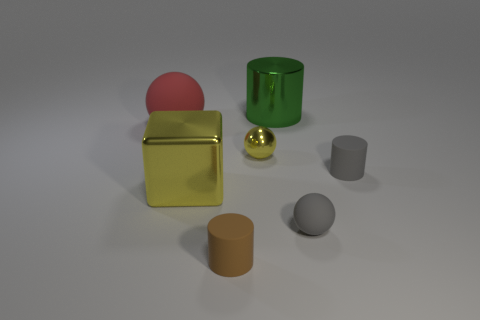Subtract all tiny rubber cylinders. How many cylinders are left? 1 Add 1 brown rubber cubes. How many objects exist? 8 Subtract all yellow balls. How many balls are left? 2 Subtract all cubes. How many objects are left? 6 Add 3 red objects. How many red objects are left? 4 Add 7 gray balls. How many gray balls exist? 8 Subtract 0 yellow cylinders. How many objects are left? 7 Subtract all green cylinders. Subtract all gray cubes. How many cylinders are left? 2 Subtract all large purple matte cylinders. Subtract all brown matte cylinders. How many objects are left? 6 